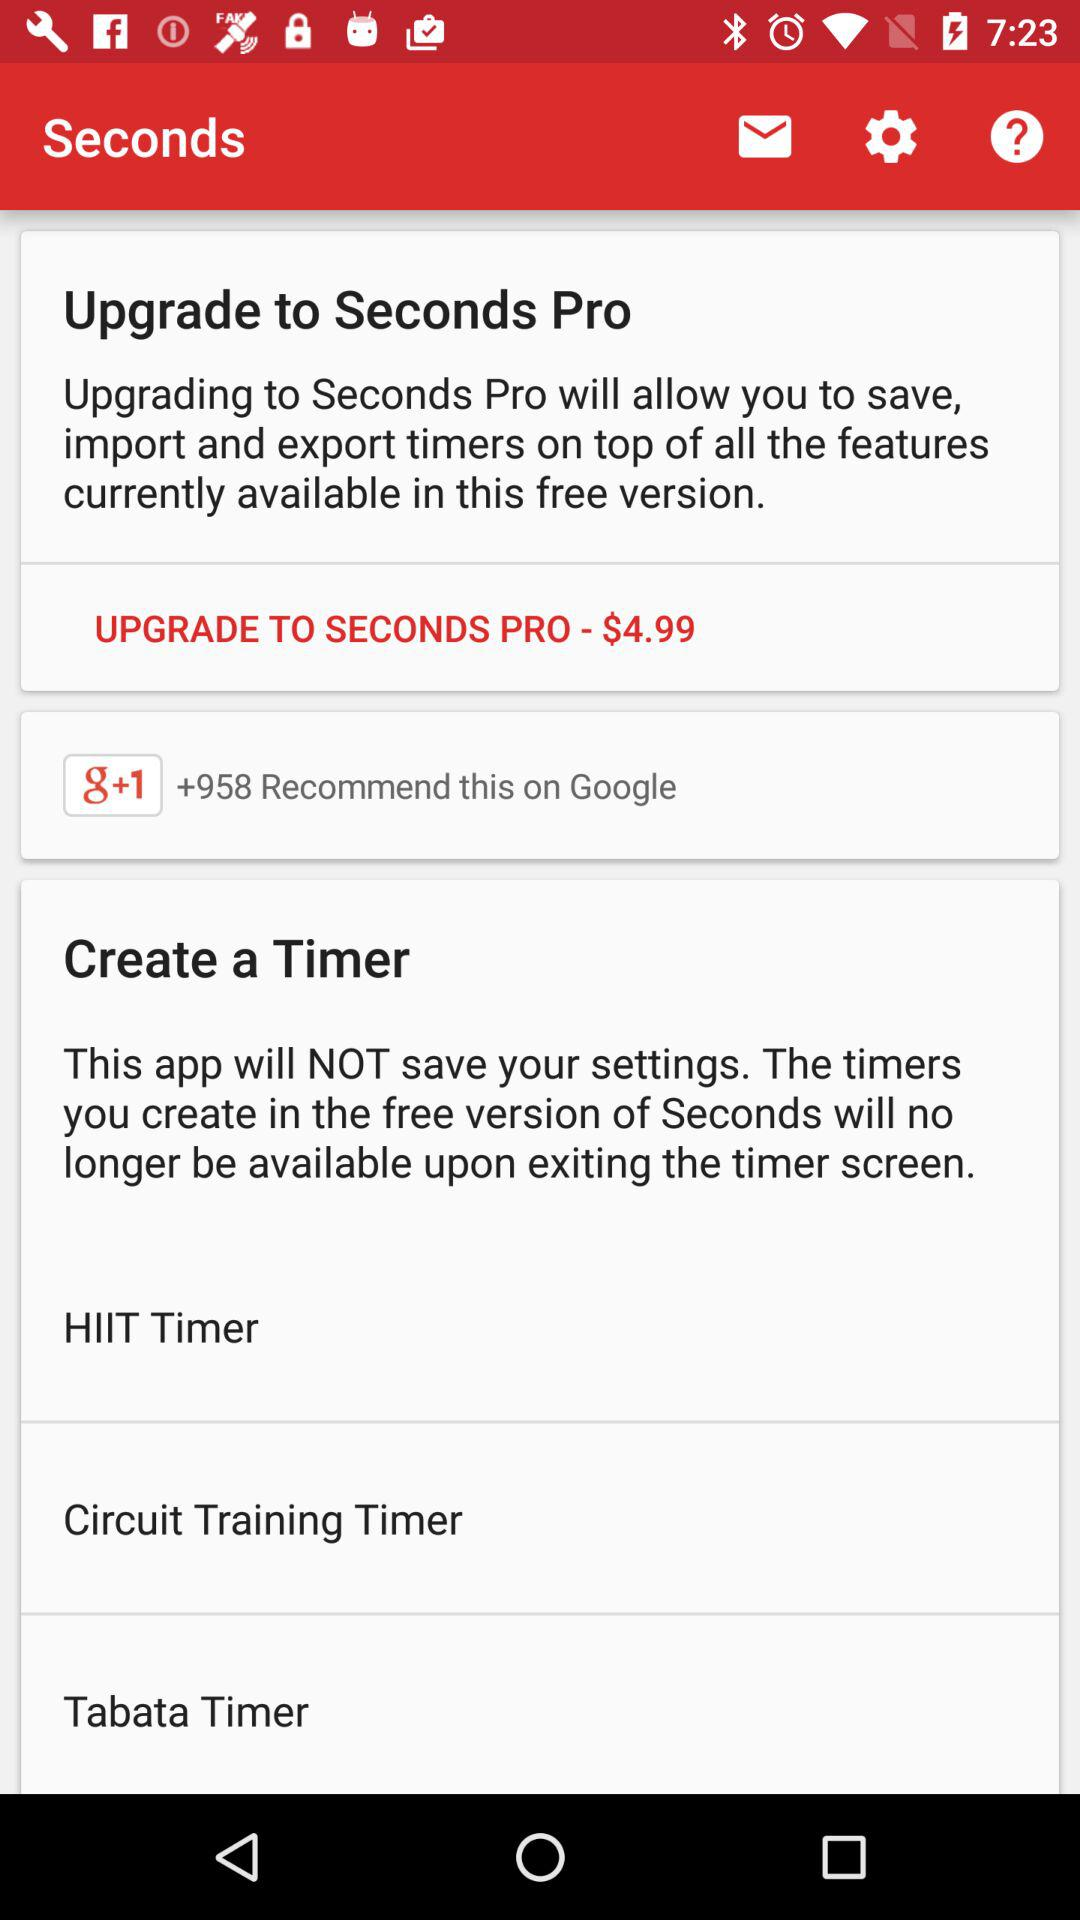How many users recommend this on "Google"? The number of users who recommend it on "Google" is 958. 